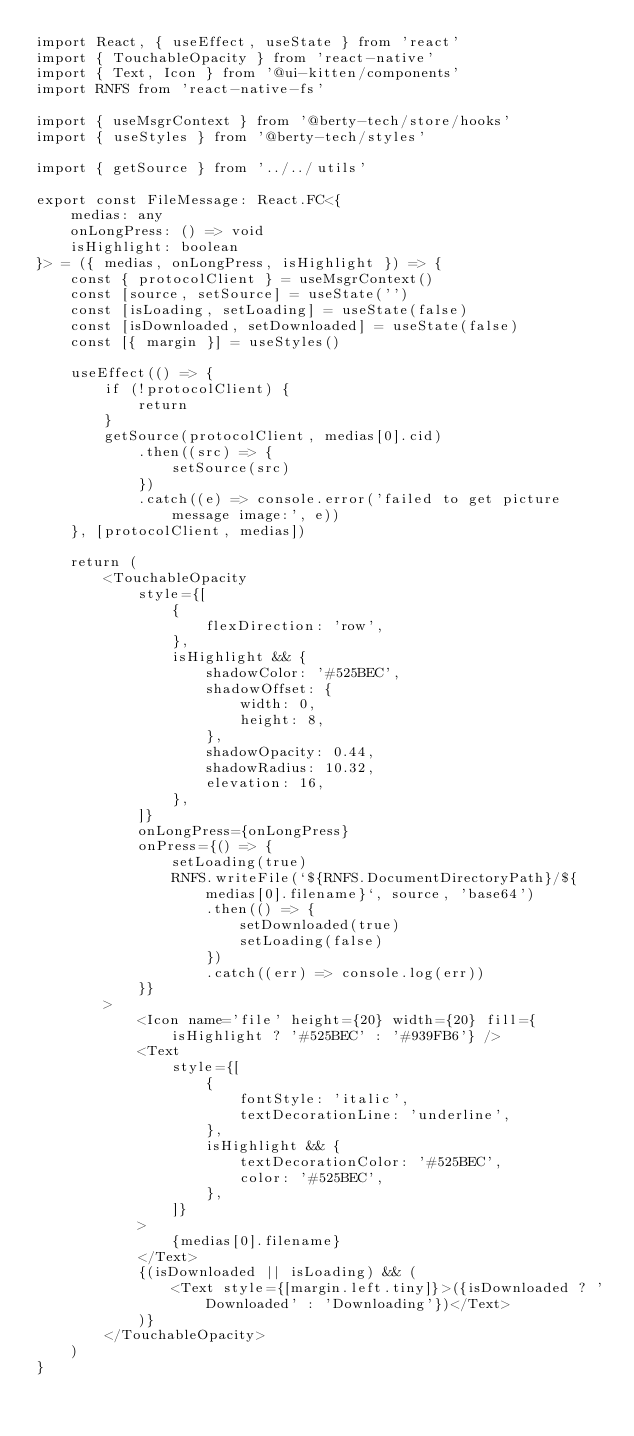<code> <loc_0><loc_0><loc_500><loc_500><_TypeScript_>import React, { useEffect, useState } from 'react'
import { TouchableOpacity } from 'react-native'
import { Text, Icon } from '@ui-kitten/components'
import RNFS from 'react-native-fs'

import { useMsgrContext } from '@berty-tech/store/hooks'
import { useStyles } from '@berty-tech/styles'

import { getSource } from '../../utils'

export const FileMessage: React.FC<{
	medias: any
	onLongPress: () => void
	isHighlight: boolean
}> = ({ medias, onLongPress, isHighlight }) => {
	const { protocolClient } = useMsgrContext()
	const [source, setSource] = useState('')
	const [isLoading, setLoading] = useState(false)
	const [isDownloaded, setDownloaded] = useState(false)
	const [{ margin }] = useStyles()

	useEffect(() => {
		if (!protocolClient) {
			return
		}
		getSource(protocolClient, medias[0].cid)
			.then((src) => {
				setSource(src)
			})
			.catch((e) => console.error('failed to get picture message image:', e))
	}, [protocolClient, medias])

	return (
		<TouchableOpacity
			style={[
				{
					flexDirection: 'row',
				},
				isHighlight && {
					shadowColor: '#525BEC',
					shadowOffset: {
						width: 0,
						height: 8,
					},
					shadowOpacity: 0.44,
					shadowRadius: 10.32,
					elevation: 16,
				},
			]}
			onLongPress={onLongPress}
			onPress={() => {
				setLoading(true)
				RNFS.writeFile(`${RNFS.DocumentDirectoryPath}/${medias[0].filename}`, source, 'base64')
					.then(() => {
						setDownloaded(true)
						setLoading(false)
					})
					.catch((err) => console.log(err))
			}}
		>
			<Icon name='file' height={20} width={20} fill={isHighlight ? '#525BEC' : '#939FB6'} />
			<Text
				style={[
					{
						fontStyle: 'italic',
						textDecorationLine: 'underline',
					},
					isHighlight && {
						textDecorationColor: '#525BEC',
						color: '#525BEC',
					},
				]}
			>
				{medias[0].filename}
			</Text>
			{(isDownloaded || isLoading) && (
				<Text style={[margin.left.tiny]}>({isDownloaded ? 'Downloaded' : 'Downloading'})</Text>
			)}
		</TouchableOpacity>
	)
}
</code> 